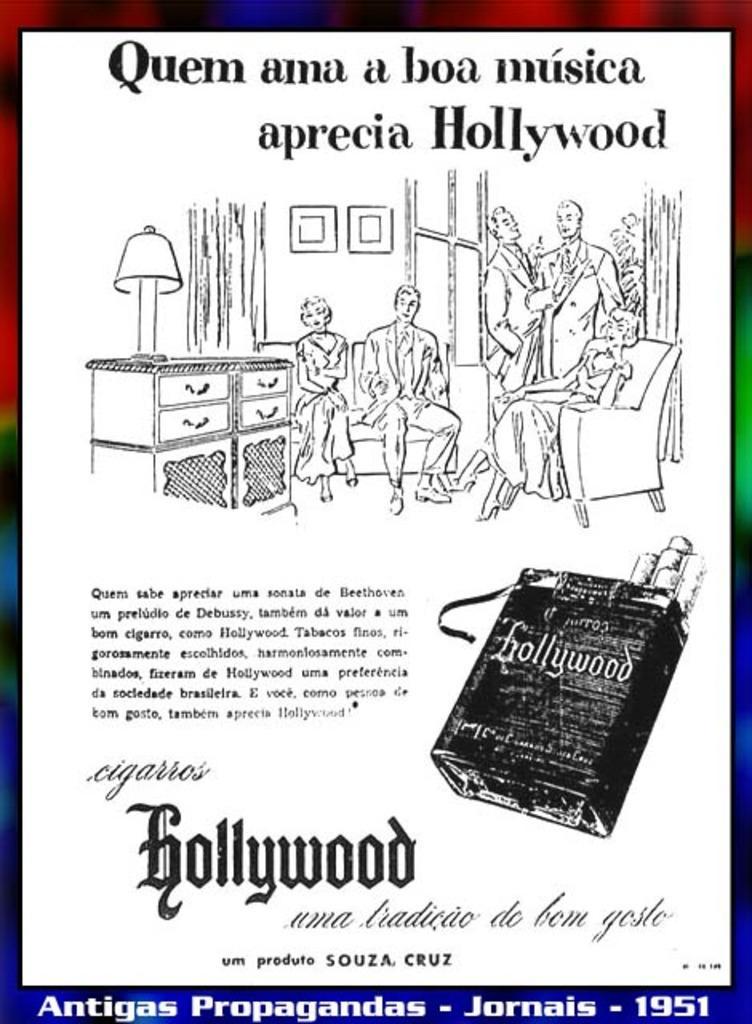How would you summarize this image in a sentence or two? In this picture we can observe sketch of some people sitting and standing in this room. We can observe a lamp on the desk. There is some text in this picture. We can observe red, blue, green and black color border in this picture. 